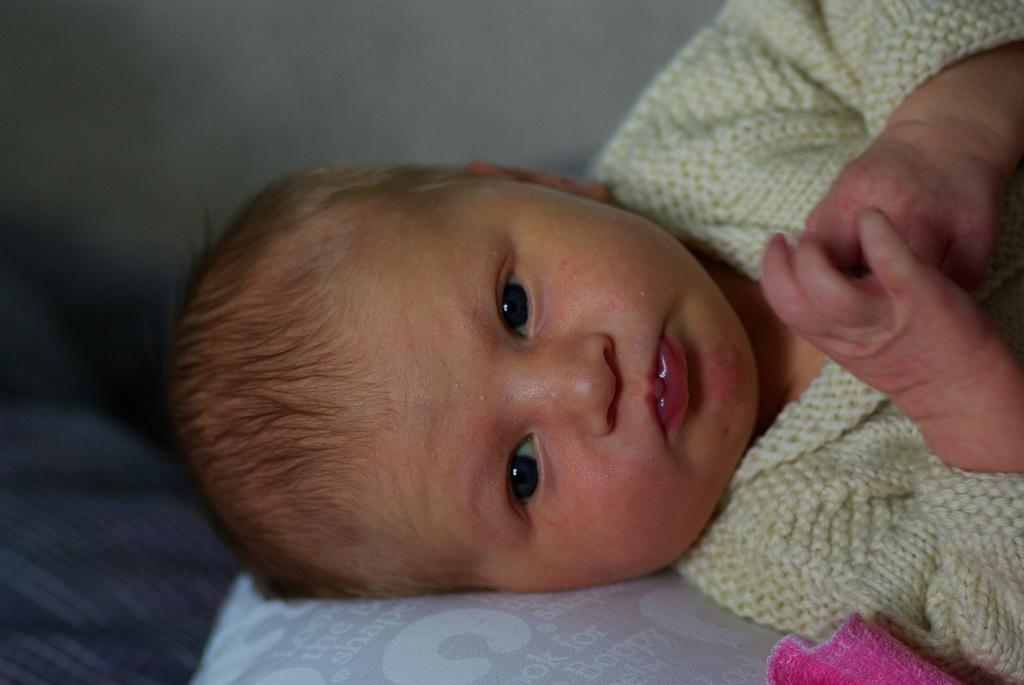What is the main subject of the picture? The main subject of the picture is a baby. What is the baby wearing in the picture? The baby is wearing a sweater in the picture. What object can be seen at the bottom portion of the picture? There is a pillow at the bottom portion of the picture. What color is the cloth visible in the image? The cloth visible in the image is pink. Where is the key located in the picture? There is no key present in the picture. What type of station is visible in the image? There is no station visible in the image. 